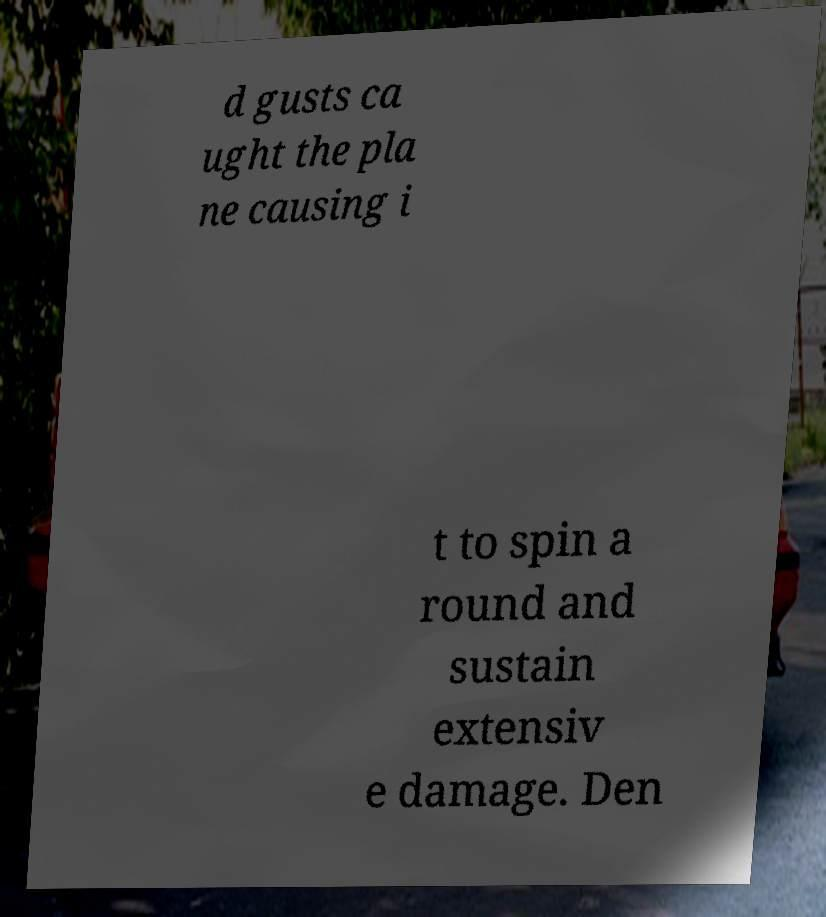Please identify and transcribe the text found in this image. d gusts ca ught the pla ne causing i t to spin a round and sustain extensiv e damage. Den 